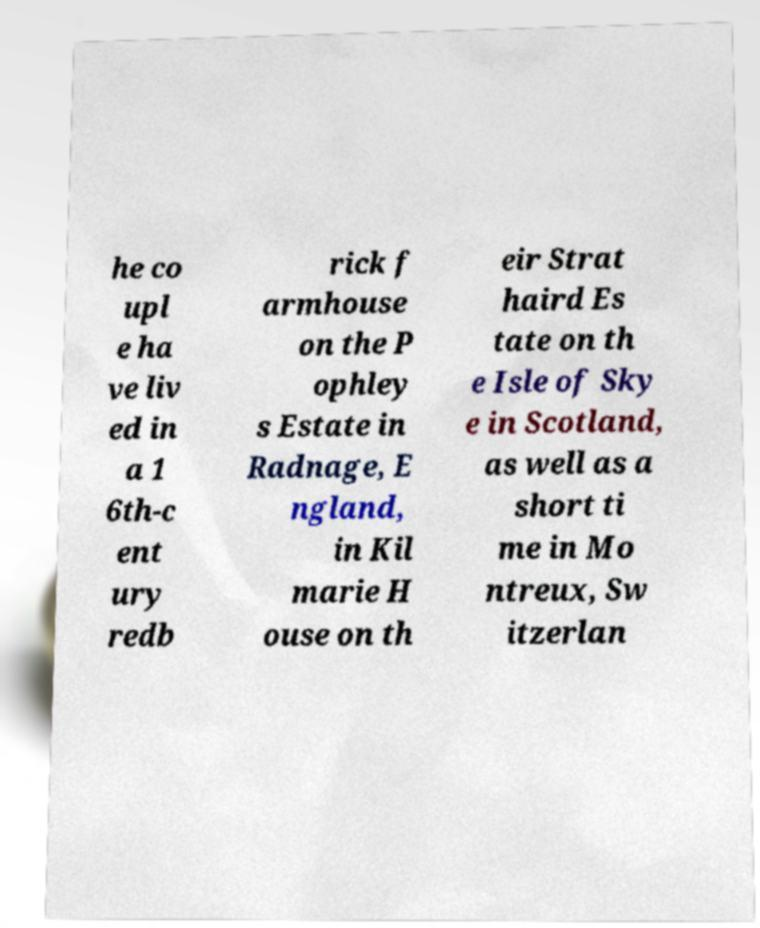Could you assist in decoding the text presented in this image and type it out clearly? he co upl e ha ve liv ed in a 1 6th-c ent ury redb rick f armhouse on the P ophley s Estate in Radnage, E ngland, in Kil marie H ouse on th eir Strat haird Es tate on th e Isle of Sky e in Scotland, as well as a short ti me in Mo ntreux, Sw itzerlan 